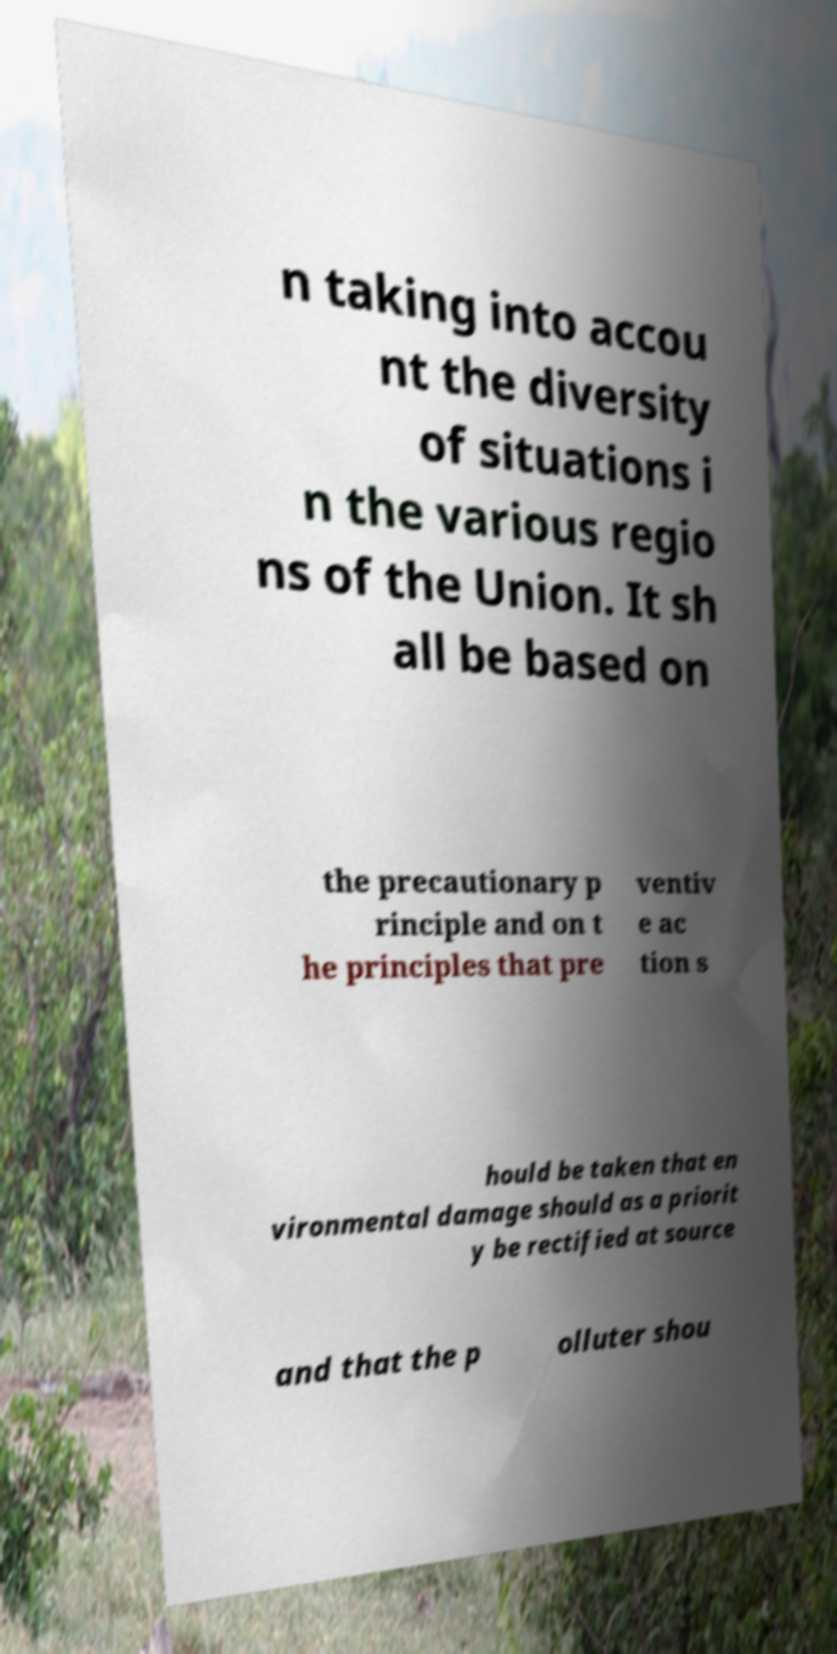Please read and relay the text visible in this image. What does it say? n taking into accou nt the diversity of situations i n the various regio ns of the Union. It sh all be based on the precautionary p rinciple and on t he principles that pre ventiv e ac tion s hould be taken that en vironmental damage should as a priorit y be rectified at source and that the p olluter shou 